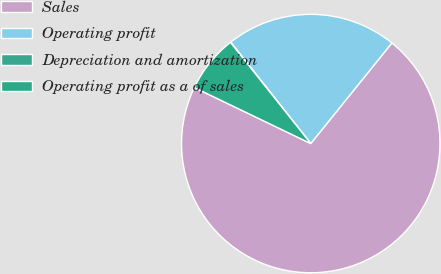<chart> <loc_0><loc_0><loc_500><loc_500><pie_chart><fcel>Sales<fcel>Operating profit<fcel>Depreciation and amortization<fcel>Operating profit as a of sales<nl><fcel>71.34%<fcel>21.44%<fcel>0.05%<fcel>7.18%<nl></chart> 